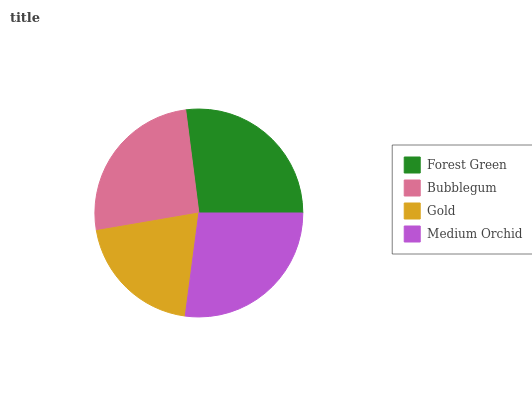Is Gold the minimum?
Answer yes or no. Yes. Is Medium Orchid the maximum?
Answer yes or no. Yes. Is Bubblegum the minimum?
Answer yes or no. No. Is Bubblegum the maximum?
Answer yes or no. No. Is Forest Green greater than Bubblegum?
Answer yes or no. Yes. Is Bubblegum less than Forest Green?
Answer yes or no. Yes. Is Bubblegum greater than Forest Green?
Answer yes or no. No. Is Forest Green less than Bubblegum?
Answer yes or no. No. Is Forest Green the high median?
Answer yes or no. Yes. Is Bubblegum the low median?
Answer yes or no. Yes. Is Bubblegum the high median?
Answer yes or no. No. Is Gold the low median?
Answer yes or no. No. 